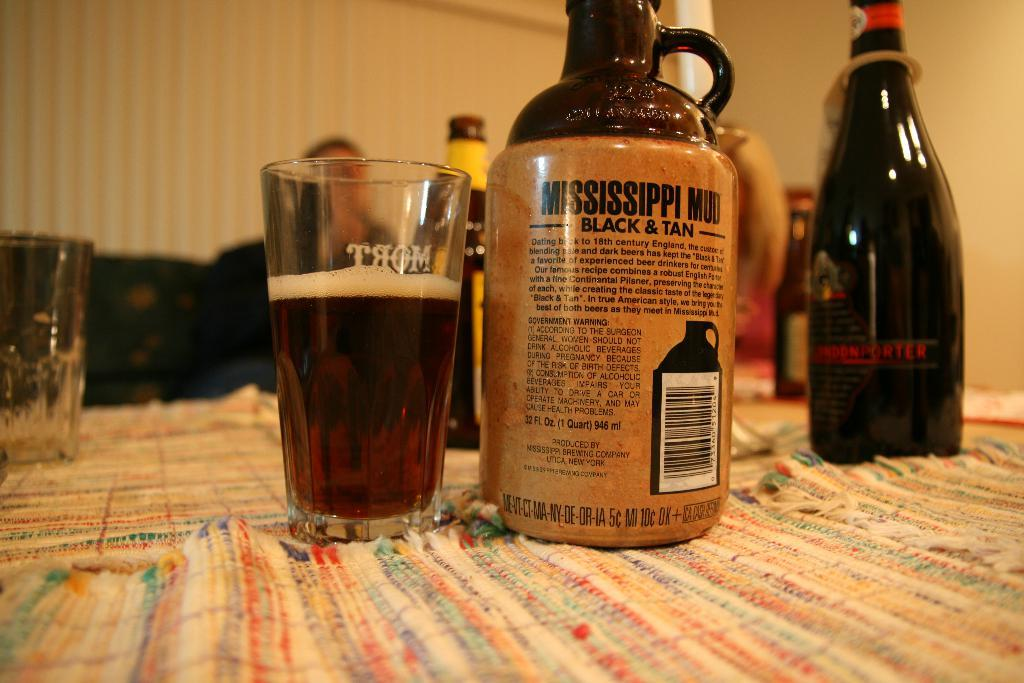<image>
Create a compact narrative representing the image presented. A bottle of Mississippi Mud Black & Tan. 